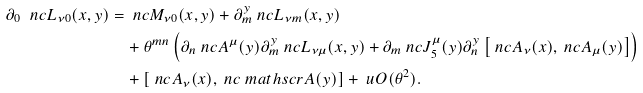<formula> <loc_0><loc_0><loc_500><loc_500>\partial _ { 0 } \ n c { L } _ { \nu 0 } ( x , y ) & = \ n c { M } _ { \nu 0 } ( x , y ) + \partial _ { m } ^ { y } \ n c { L } _ { \nu m } ( x , y ) \\ & \quad + \theta ^ { m n } \left ( \partial _ { n } \ n c { A } ^ { \mu } ( y ) \partial _ { m } ^ { y } \ n c { L } _ { \nu \mu } ( x , y ) + \partial _ { m } \ n c { J } ^ { \mu } _ { 5 } ( y ) \partial _ { n } ^ { y } \left [ \ n c { A } _ { \nu } ( x ) , \ n c { A } _ { \mu } ( y ) \right ] \right ) \\ & \quad + \left [ \ n c { A } _ { \nu } ( x ) , \ n c { \ m a t h s c r { A } } ( y ) \right ] + \ u O ( \theta ^ { 2 } ) .</formula> 